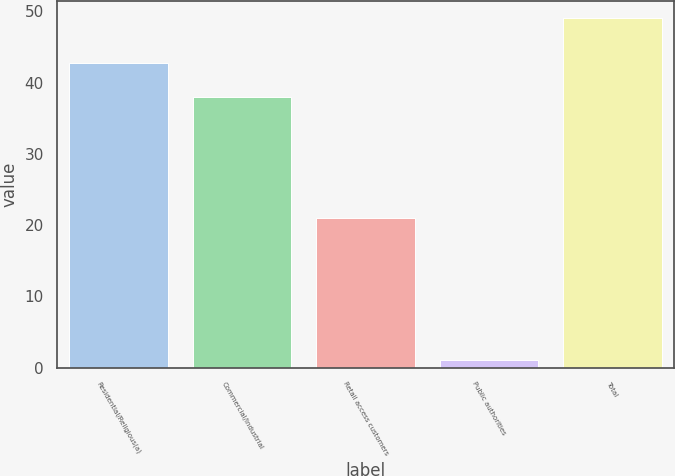Convert chart to OTSL. <chart><loc_0><loc_0><loc_500><loc_500><bar_chart><fcel>Residential/Religious(a)<fcel>Commercial/Industrial<fcel>Retail access customers<fcel>Public authorities<fcel>Total<nl><fcel>42.8<fcel>38<fcel>21<fcel>1<fcel>49<nl></chart> 